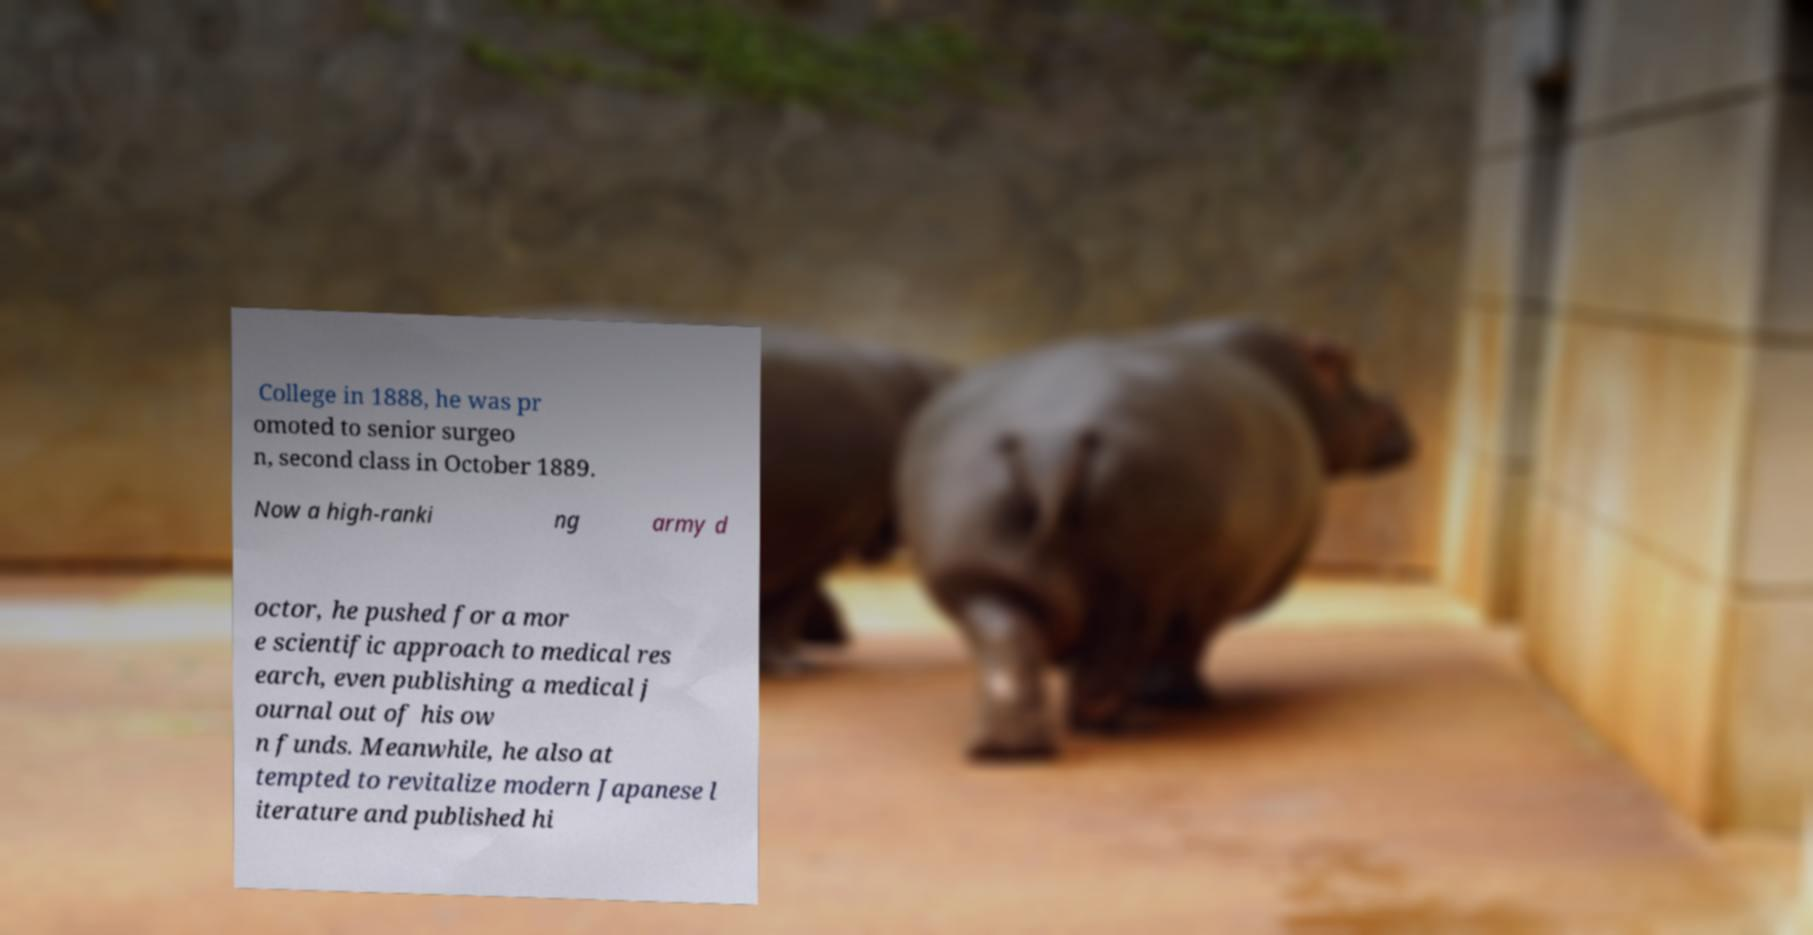Can you read and provide the text displayed in the image?This photo seems to have some interesting text. Can you extract and type it out for me? College in 1888, he was pr omoted to senior surgeo n, second class in October 1889. Now a high-ranki ng army d octor, he pushed for a mor e scientific approach to medical res earch, even publishing a medical j ournal out of his ow n funds. Meanwhile, he also at tempted to revitalize modern Japanese l iterature and published hi 